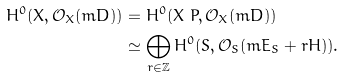<formula> <loc_0><loc_0><loc_500><loc_500>H ^ { 0 } ( X , \mathcal { O } _ { X } ( m D ) ) & = H ^ { 0 } ( X \ P , \mathcal { O } _ { X } ( m D ) ) \\ & \simeq \bigoplus _ { r \in \mathbb { Z } } H ^ { 0 } ( S , \mathcal { O } _ { S } ( m E _ { S } + r H ) ) .</formula> 